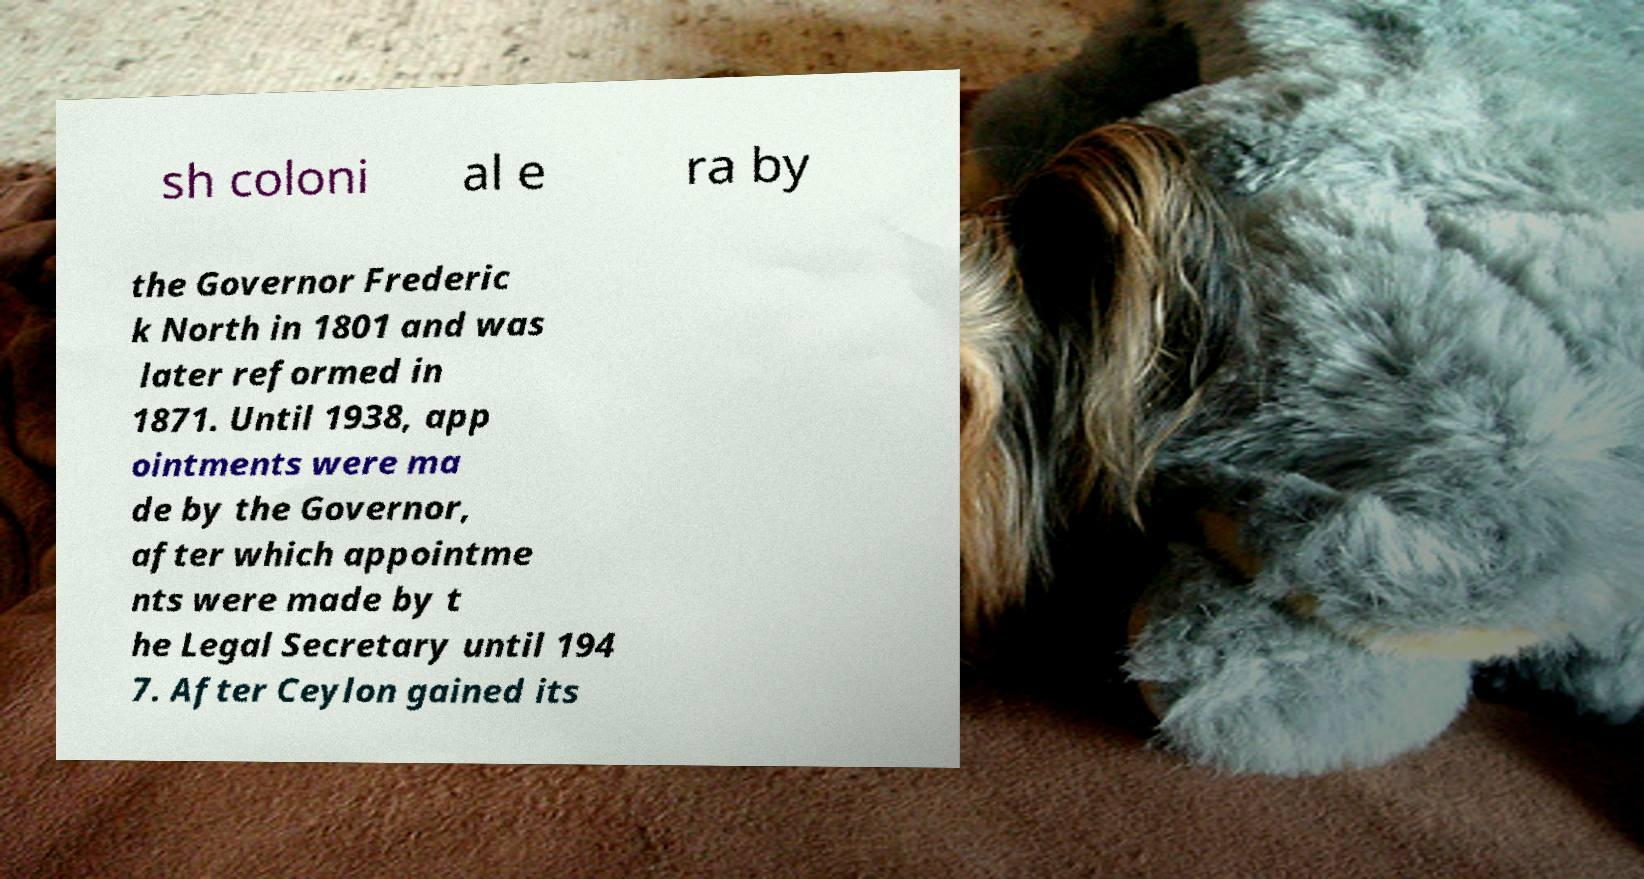I need the written content from this picture converted into text. Can you do that? sh coloni al e ra by the Governor Frederic k North in 1801 and was later reformed in 1871. Until 1938, app ointments were ma de by the Governor, after which appointme nts were made by t he Legal Secretary until 194 7. After Ceylon gained its 